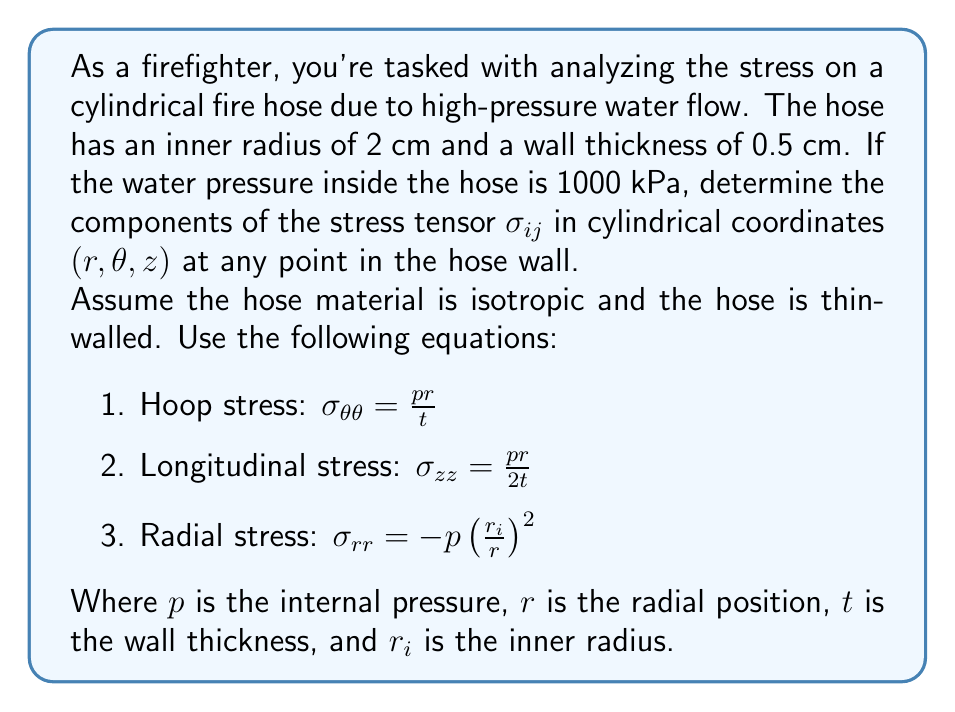Show me your answer to this math problem. Let's approach this step-by-step:

1) First, let's identify our known values:
   - Inner radius, $r_i = 2$ cm
   - Wall thickness, $t = 0.5$ cm
   - Internal pressure, $p = 1000$ kPa

2) For the hoop stress $\sigma_{\theta\theta}$:
   $$\sigma_{\theta\theta} = \frac{pr}{t} = \frac{1000 \cdot 2}{0.5} = 4000 \text{ kPa}$$

3) For the longitudinal stress $\sigma_{zz}$:
   $$\sigma_{zz} = \frac{pr}{2t} = \frac{1000 \cdot 2}{2 \cdot 0.5} = 2000 \text{ kPa}$$

4) For the radial stress $\sigma_{rr}$, we need to consider that it varies with $r$:
   $$\sigma_{rr} = -p(\frac{r_i}{r})^2 = -1000(\frac{2}{r})^2 \text{ kPa}$$
   This will be maximum (in magnitude) at the inner surface where $r = r_i = 2$ cm:
   $$\sigma_{rr} = -1000(\frac{2}{2})^2 = -1000 \text{ kPa}$$
   And it will be minimum (zero) at the outer surface where $r = r_i + t = 2.5$ cm.

5) All other components of the stress tensor ($\sigma_{r\theta}, \sigma_{rz}, \sigma_{\theta z}$) are zero due to symmetry.

6) Therefore, the stress tensor in cylindrical coordinates is:

   $$\sigma_{ij} = \begin{bmatrix}
   \sigma_{rr} & 0 & 0 \\
   0 & \sigma_{\theta\theta} & 0 \\
   0 & 0 & \sigma_{zz}
   \end{bmatrix} = \begin{bmatrix}
   -1000(\frac{2}{r})^2 & 0 & 0 \\
   0 & 4000 & 0 \\
   0 & 0 & 2000
   \end{bmatrix} \text{ kPa}$$

   where $2 \text{ cm} \leq r \leq 2.5 \text{ cm}$
Answer: $$\sigma_{ij} = \begin{bmatrix}
-1000(\frac{2}{r})^2 & 0 & 0 \\
0 & 4000 & 0 \\
0 & 0 & 2000
\end{bmatrix} \text{ kPa}, \; 2 \text{ cm} \leq r \leq 2.5 \text{ cm}$$ 